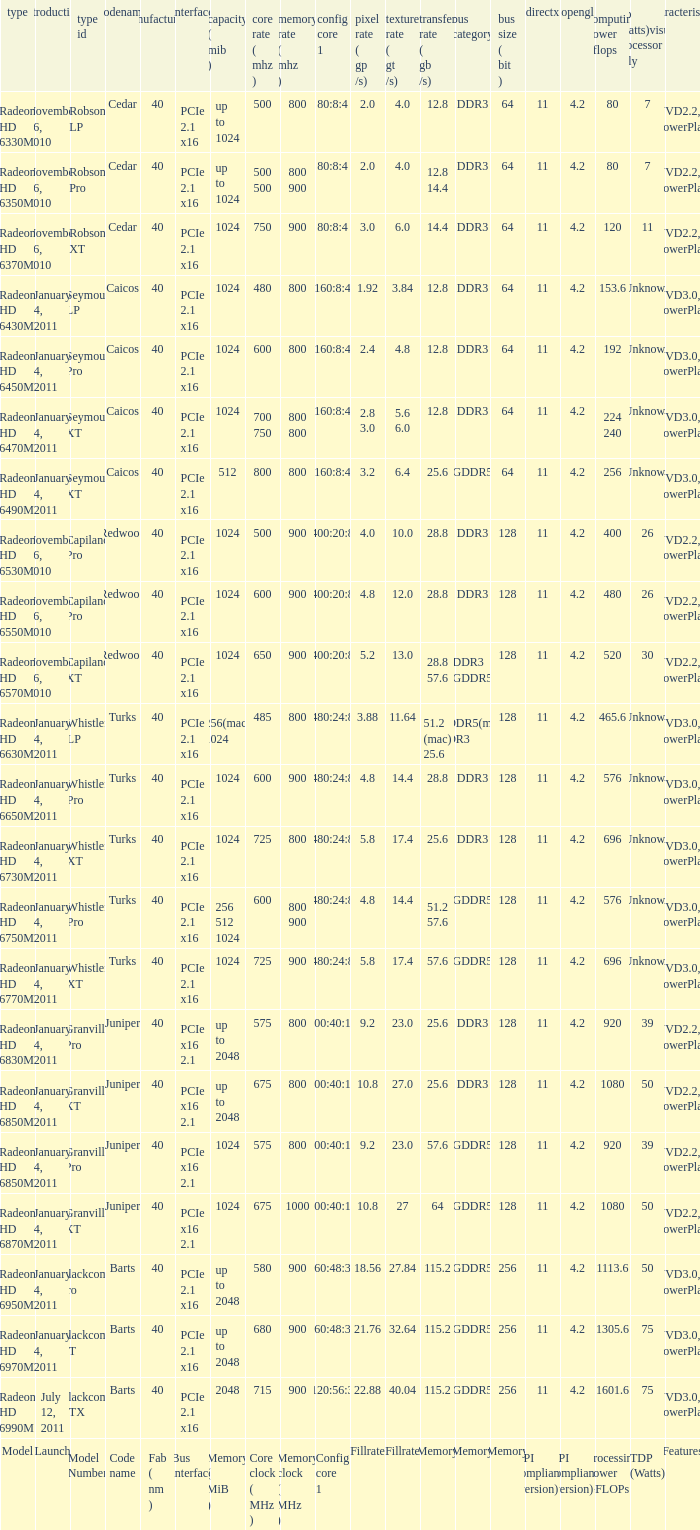How many values for bus width possess a bandwidth of 2 1.0. 